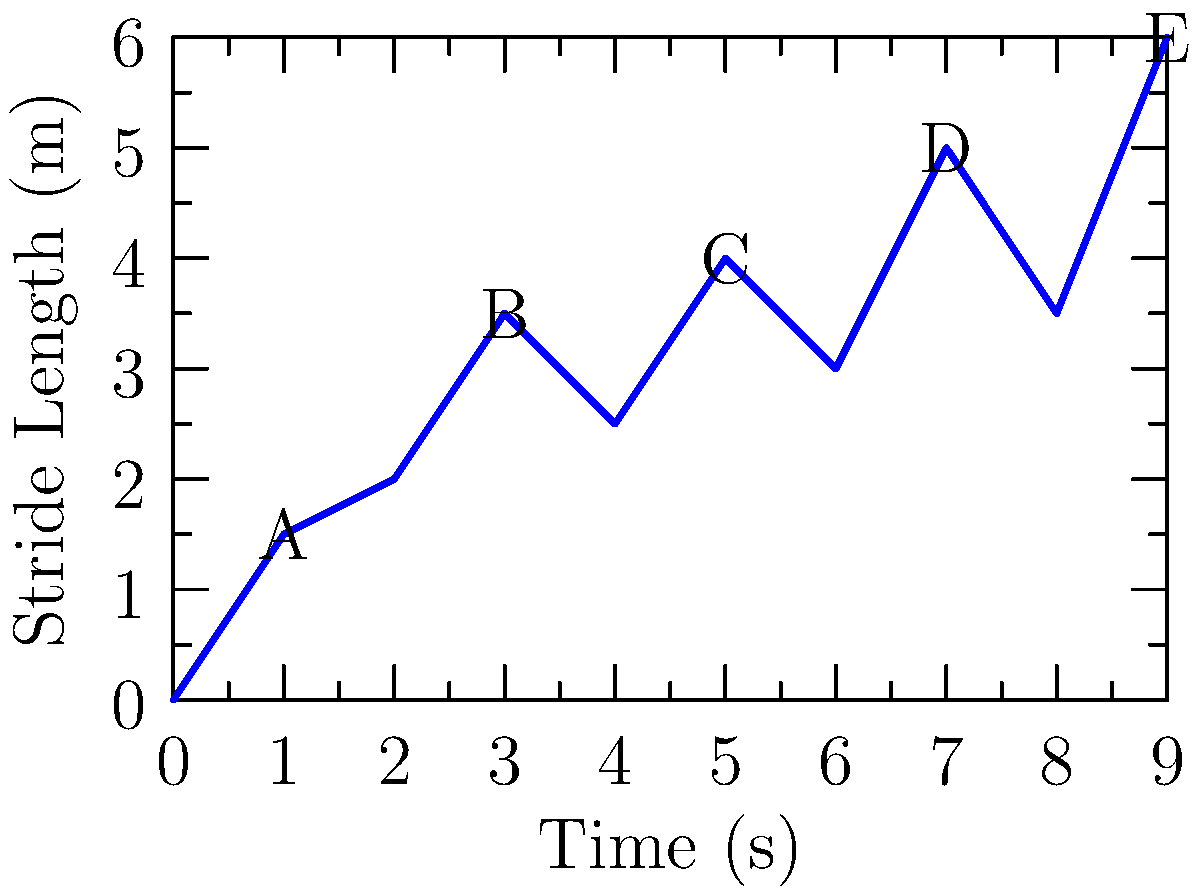In the topological analysis of stride length patterns for a race walker, the graph shows the relationship between time and stride length. Using persistent homology, how many significant topological features (i.e., connected components) are present in this data when considering a filtration based on stride length? To analyze this data using persistent homology:

1. We consider a filtration based on stride length, starting from the lowest point and gradually increasing.

2. At the lowest level, we have one point (0,0), forming one connected component.

3. As we increase the stride length:
   - At y ≈ 1.5m, point A joins, still one component.
   - At y ≈ 2m, a new component forms.
   - At y ≈ 2.5m, another new component forms.
   - At y ≈ 3m, the component from y ≈ 2m merges with the main component.
   - At y ≈ 3.5m, points B and D join, merging the y ≈ 2.5m component.
   - At y = 4m, point C joins the main component.
   - At y = 5m, point D is already part of the main component.
   - At y = 6m, point E joins the main component.

4. Throughout this process, we observe three significant connected components:
   - The main component starting at (0,0)
   - A short-lived component forming at y ≈ 2m
   - Another short-lived component forming at y ≈ 2.5m

5. The two short-lived components merge into the main component as the filtration progresses, but they represent distinct topological features in the stride pattern.

Therefore, the persistent homology analysis reveals 3 significant topological features in this stride length pattern data.
Answer: 3 